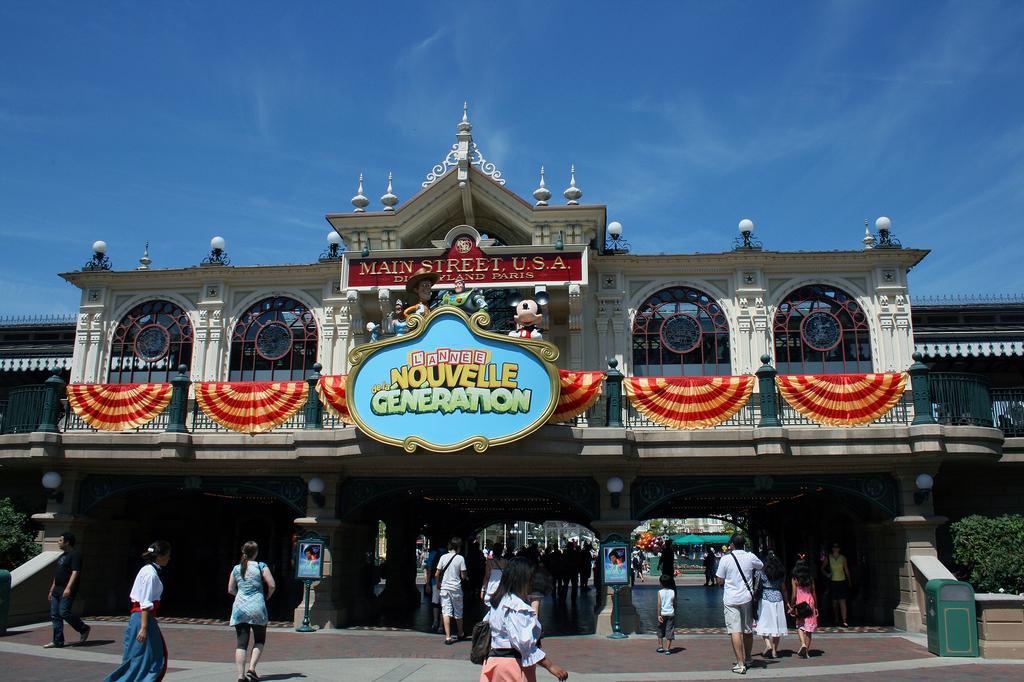Can you describe this image briefly? In the picture there is a building. There are people outside and inside the building. There are glass windows and railing. There is cloth spread on railing. There is a board with text on it hanging to the railing. There are lights above the building. There are hedges to the extreme corners of the image. To the above there is sky. 